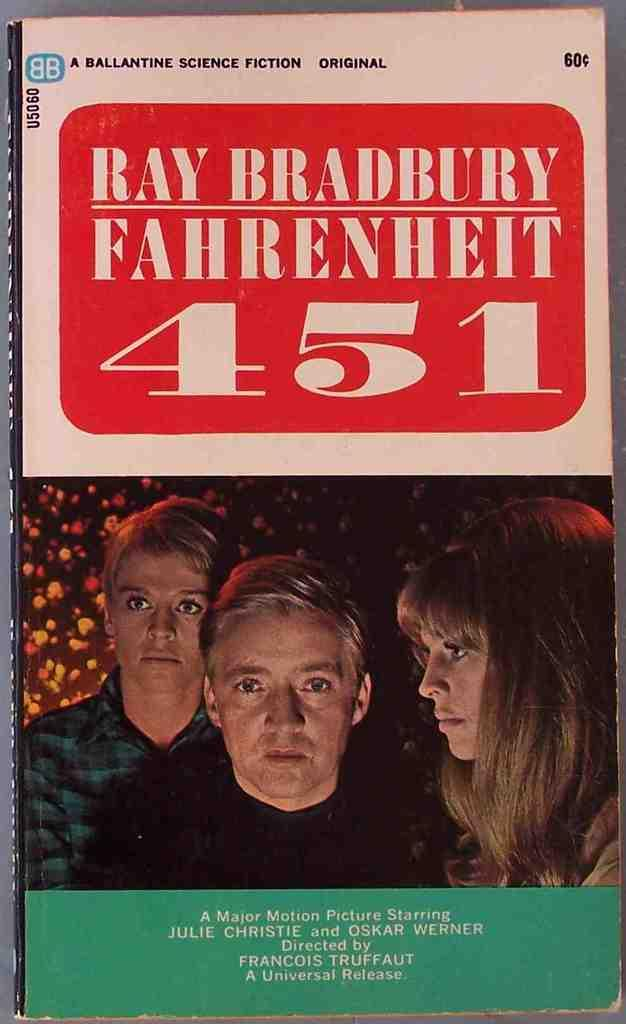What is the main subject in the center of the image? There is a book in the center of the image. What can be seen on the front page of the book? There are persons depicted on the front page of the book. What else is present in the image besides the book? There is text present in the image. Where is the bun located in the image? There is no bun present in the image; it is not mentioned in the provided facts. 